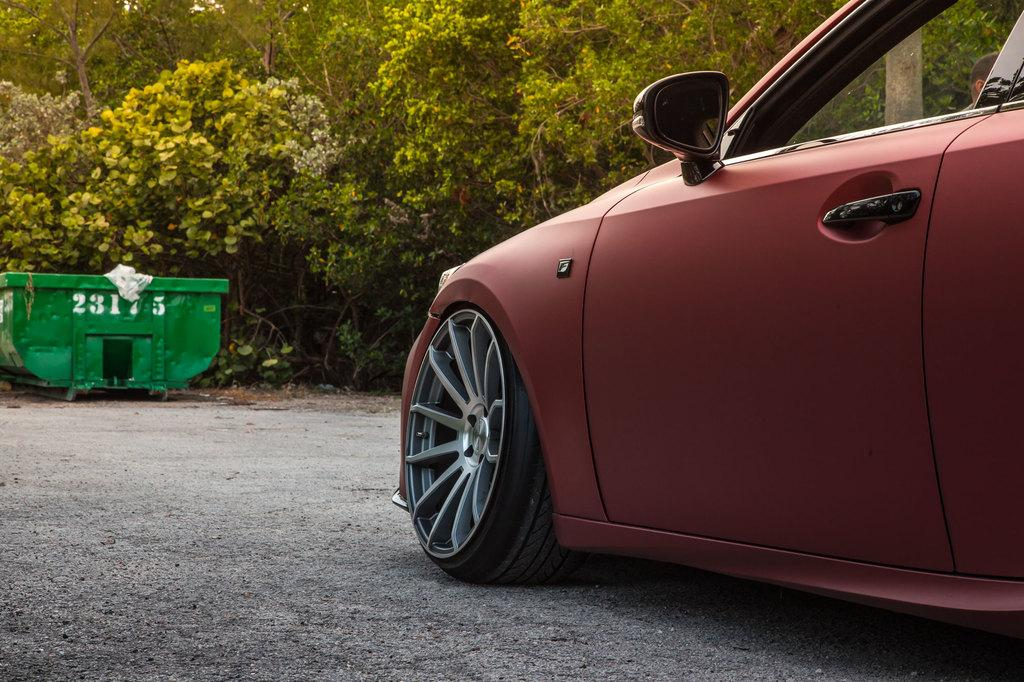What is the main subject of the image? The image depicts a road. Is there any vehicle on the road? Yes, there is a car on the road. What else can be seen in the image besides the road and car? There is an object at the back of the image and trees are present. Where is the road located in the image? The road is visible at the bottom of the image. How many chickens are crossing the road in the image? There are no chickens present in the image; it only depicts a road, a car, an object at the back, trees, and the location of the road. 